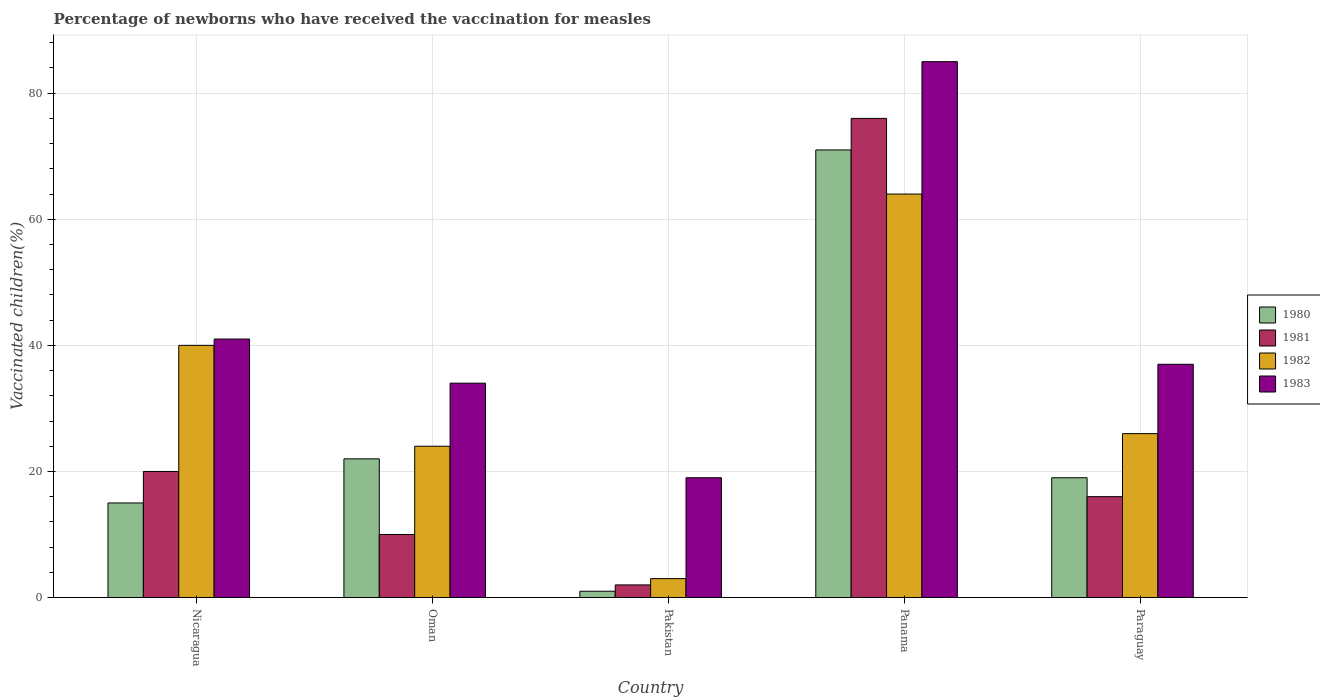How many groups of bars are there?
Offer a very short reply. 5. How many bars are there on the 1st tick from the right?
Offer a very short reply. 4. What is the label of the 2nd group of bars from the left?
Provide a succinct answer. Oman. In how many cases, is the number of bars for a given country not equal to the number of legend labels?
Provide a short and direct response. 0. What is the percentage of vaccinated children in 1983 in Pakistan?
Your answer should be compact. 19. Across all countries, what is the maximum percentage of vaccinated children in 1980?
Provide a short and direct response. 71. In which country was the percentage of vaccinated children in 1981 maximum?
Your answer should be very brief. Panama. What is the total percentage of vaccinated children in 1980 in the graph?
Give a very brief answer. 128. What is the difference between the percentage of vaccinated children in 1982 in Oman and the percentage of vaccinated children in 1981 in Panama?
Provide a short and direct response. -52. What is the average percentage of vaccinated children in 1980 per country?
Give a very brief answer. 25.6. What is the difference between the percentage of vaccinated children of/in 1982 and percentage of vaccinated children of/in 1981 in Oman?
Provide a short and direct response. 14. In how many countries, is the percentage of vaccinated children in 1983 greater than 44 %?
Provide a succinct answer. 1. What is the ratio of the percentage of vaccinated children in 1981 in Nicaragua to that in Paraguay?
Keep it short and to the point. 1.25. Is the percentage of vaccinated children in 1980 in Pakistan less than that in Panama?
Your answer should be very brief. Yes. What is the difference between the highest and the second highest percentage of vaccinated children in 1981?
Offer a very short reply. -60. What is the difference between the highest and the lowest percentage of vaccinated children in 1981?
Your answer should be compact. 74. In how many countries, is the percentage of vaccinated children in 1982 greater than the average percentage of vaccinated children in 1982 taken over all countries?
Provide a short and direct response. 2. Is it the case that in every country, the sum of the percentage of vaccinated children in 1982 and percentage of vaccinated children in 1980 is greater than the sum of percentage of vaccinated children in 1983 and percentage of vaccinated children in 1981?
Your answer should be compact. No. What is the difference between two consecutive major ticks on the Y-axis?
Keep it short and to the point. 20. Where does the legend appear in the graph?
Offer a very short reply. Center right. How many legend labels are there?
Give a very brief answer. 4. What is the title of the graph?
Your answer should be very brief. Percentage of newborns who have received the vaccination for measles. Does "2006" appear as one of the legend labels in the graph?
Offer a terse response. No. What is the label or title of the X-axis?
Your response must be concise. Country. What is the label or title of the Y-axis?
Keep it short and to the point. Vaccinated children(%). What is the Vaccinated children(%) in 1980 in Nicaragua?
Keep it short and to the point. 15. What is the Vaccinated children(%) in 1981 in Pakistan?
Make the answer very short. 2. What is the Vaccinated children(%) in 1983 in Panama?
Provide a short and direct response. 85. What is the Vaccinated children(%) of 1982 in Paraguay?
Your response must be concise. 26. What is the Vaccinated children(%) of 1983 in Paraguay?
Your answer should be very brief. 37. Across all countries, what is the maximum Vaccinated children(%) in 1980?
Provide a succinct answer. 71. Across all countries, what is the maximum Vaccinated children(%) in 1981?
Offer a very short reply. 76. Across all countries, what is the maximum Vaccinated children(%) of 1983?
Your response must be concise. 85. Across all countries, what is the minimum Vaccinated children(%) of 1982?
Give a very brief answer. 3. Across all countries, what is the minimum Vaccinated children(%) in 1983?
Ensure brevity in your answer.  19. What is the total Vaccinated children(%) in 1980 in the graph?
Offer a terse response. 128. What is the total Vaccinated children(%) in 1981 in the graph?
Your answer should be compact. 124. What is the total Vaccinated children(%) in 1982 in the graph?
Give a very brief answer. 157. What is the total Vaccinated children(%) of 1983 in the graph?
Give a very brief answer. 216. What is the difference between the Vaccinated children(%) in 1981 in Nicaragua and that in Oman?
Your answer should be compact. 10. What is the difference between the Vaccinated children(%) in 1982 in Nicaragua and that in Oman?
Your answer should be very brief. 16. What is the difference between the Vaccinated children(%) of 1980 in Nicaragua and that in Panama?
Provide a short and direct response. -56. What is the difference between the Vaccinated children(%) of 1981 in Nicaragua and that in Panama?
Provide a short and direct response. -56. What is the difference between the Vaccinated children(%) in 1983 in Nicaragua and that in Panama?
Your answer should be very brief. -44. What is the difference between the Vaccinated children(%) of 1983 in Nicaragua and that in Paraguay?
Make the answer very short. 4. What is the difference between the Vaccinated children(%) in 1980 in Oman and that in Pakistan?
Your response must be concise. 21. What is the difference between the Vaccinated children(%) in 1981 in Oman and that in Pakistan?
Ensure brevity in your answer.  8. What is the difference between the Vaccinated children(%) in 1982 in Oman and that in Pakistan?
Provide a succinct answer. 21. What is the difference between the Vaccinated children(%) of 1983 in Oman and that in Pakistan?
Your answer should be compact. 15. What is the difference between the Vaccinated children(%) of 1980 in Oman and that in Panama?
Ensure brevity in your answer.  -49. What is the difference between the Vaccinated children(%) of 1981 in Oman and that in Panama?
Provide a short and direct response. -66. What is the difference between the Vaccinated children(%) in 1983 in Oman and that in Panama?
Provide a short and direct response. -51. What is the difference between the Vaccinated children(%) in 1983 in Oman and that in Paraguay?
Give a very brief answer. -3. What is the difference between the Vaccinated children(%) in 1980 in Pakistan and that in Panama?
Your answer should be very brief. -70. What is the difference between the Vaccinated children(%) of 1981 in Pakistan and that in Panama?
Keep it short and to the point. -74. What is the difference between the Vaccinated children(%) of 1982 in Pakistan and that in Panama?
Provide a short and direct response. -61. What is the difference between the Vaccinated children(%) in 1983 in Pakistan and that in Panama?
Give a very brief answer. -66. What is the difference between the Vaccinated children(%) of 1980 in Pakistan and that in Paraguay?
Offer a terse response. -18. What is the difference between the Vaccinated children(%) in 1981 in Pakistan and that in Paraguay?
Ensure brevity in your answer.  -14. What is the difference between the Vaccinated children(%) in 1981 in Panama and that in Paraguay?
Provide a succinct answer. 60. What is the difference between the Vaccinated children(%) in 1980 in Nicaragua and the Vaccinated children(%) in 1982 in Oman?
Offer a very short reply. -9. What is the difference between the Vaccinated children(%) in 1980 in Nicaragua and the Vaccinated children(%) in 1983 in Oman?
Ensure brevity in your answer.  -19. What is the difference between the Vaccinated children(%) in 1981 in Nicaragua and the Vaccinated children(%) in 1982 in Oman?
Your response must be concise. -4. What is the difference between the Vaccinated children(%) of 1980 in Nicaragua and the Vaccinated children(%) of 1981 in Pakistan?
Provide a short and direct response. 13. What is the difference between the Vaccinated children(%) of 1980 in Nicaragua and the Vaccinated children(%) of 1982 in Pakistan?
Make the answer very short. 12. What is the difference between the Vaccinated children(%) of 1980 in Nicaragua and the Vaccinated children(%) of 1981 in Panama?
Give a very brief answer. -61. What is the difference between the Vaccinated children(%) in 1980 in Nicaragua and the Vaccinated children(%) in 1982 in Panama?
Your response must be concise. -49. What is the difference between the Vaccinated children(%) in 1980 in Nicaragua and the Vaccinated children(%) in 1983 in Panama?
Offer a terse response. -70. What is the difference between the Vaccinated children(%) in 1981 in Nicaragua and the Vaccinated children(%) in 1982 in Panama?
Provide a short and direct response. -44. What is the difference between the Vaccinated children(%) of 1981 in Nicaragua and the Vaccinated children(%) of 1983 in Panama?
Your answer should be very brief. -65. What is the difference between the Vaccinated children(%) of 1982 in Nicaragua and the Vaccinated children(%) of 1983 in Panama?
Offer a terse response. -45. What is the difference between the Vaccinated children(%) of 1980 in Nicaragua and the Vaccinated children(%) of 1982 in Paraguay?
Make the answer very short. -11. What is the difference between the Vaccinated children(%) in 1981 in Nicaragua and the Vaccinated children(%) in 1982 in Paraguay?
Keep it short and to the point. -6. What is the difference between the Vaccinated children(%) of 1981 in Nicaragua and the Vaccinated children(%) of 1983 in Paraguay?
Make the answer very short. -17. What is the difference between the Vaccinated children(%) in 1980 in Oman and the Vaccinated children(%) in 1981 in Pakistan?
Provide a succinct answer. 20. What is the difference between the Vaccinated children(%) of 1980 in Oman and the Vaccinated children(%) of 1983 in Pakistan?
Give a very brief answer. 3. What is the difference between the Vaccinated children(%) in 1981 in Oman and the Vaccinated children(%) in 1983 in Pakistan?
Offer a very short reply. -9. What is the difference between the Vaccinated children(%) of 1980 in Oman and the Vaccinated children(%) of 1981 in Panama?
Provide a short and direct response. -54. What is the difference between the Vaccinated children(%) in 1980 in Oman and the Vaccinated children(%) in 1982 in Panama?
Your answer should be compact. -42. What is the difference between the Vaccinated children(%) in 1980 in Oman and the Vaccinated children(%) in 1983 in Panama?
Offer a terse response. -63. What is the difference between the Vaccinated children(%) of 1981 in Oman and the Vaccinated children(%) of 1982 in Panama?
Provide a short and direct response. -54. What is the difference between the Vaccinated children(%) of 1981 in Oman and the Vaccinated children(%) of 1983 in Panama?
Offer a very short reply. -75. What is the difference between the Vaccinated children(%) of 1982 in Oman and the Vaccinated children(%) of 1983 in Panama?
Your answer should be compact. -61. What is the difference between the Vaccinated children(%) in 1982 in Oman and the Vaccinated children(%) in 1983 in Paraguay?
Your answer should be very brief. -13. What is the difference between the Vaccinated children(%) of 1980 in Pakistan and the Vaccinated children(%) of 1981 in Panama?
Ensure brevity in your answer.  -75. What is the difference between the Vaccinated children(%) in 1980 in Pakistan and the Vaccinated children(%) in 1982 in Panama?
Your answer should be compact. -63. What is the difference between the Vaccinated children(%) in 1980 in Pakistan and the Vaccinated children(%) in 1983 in Panama?
Your answer should be compact. -84. What is the difference between the Vaccinated children(%) of 1981 in Pakistan and the Vaccinated children(%) of 1982 in Panama?
Provide a short and direct response. -62. What is the difference between the Vaccinated children(%) of 1981 in Pakistan and the Vaccinated children(%) of 1983 in Panama?
Ensure brevity in your answer.  -83. What is the difference between the Vaccinated children(%) in 1982 in Pakistan and the Vaccinated children(%) in 1983 in Panama?
Keep it short and to the point. -82. What is the difference between the Vaccinated children(%) in 1980 in Pakistan and the Vaccinated children(%) in 1981 in Paraguay?
Your answer should be compact. -15. What is the difference between the Vaccinated children(%) of 1980 in Pakistan and the Vaccinated children(%) of 1983 in Paraguay?
Your answer should be compact. -36. What is the difference between the Vaccinated children(%) of 1981 in Pakistan and the Vaccinated children(%) of 1982 in Paraguay?
Your answer should be very brief. -24. What is the difference between the Vaccinated children(%) in 1981 in Pakistan and the Vaccinated children(%) in 1983 in Paraguay?
Make the answer very short. -35. What is the difference between the Vaccinated children(%) of 1982 in Pakistan and the Vaccinated children(%) of 1983 in Paraguay?
Provide a succinct answer. -34. What is the difference between the Vaccinated children(%) in 1980 in Panama and the Vaccinated children(%) in 1981 in Paraguay?
Ensure brevity in your answer.  55. What is the difference between the Vaccinated children(%) in 1980 in Panama and the Vaccinated children(%) in 1982 in Paraguay?
Provide a succinct answer. 45. What is the difference between the Vaccinated children(%) in 1981 in Panama and the Vaccinated children(%) in 1983 in Paraguay?
Ensure brevity in your answer.  39. What is the difference between the Vaccinated children(%) of 1982 in Panama and the Vaccinated children(%) of 1983 in Paraguay?
Give a very brief answer. 27. What is the average Vaccinated children(%) of 1980 per country?
Provide a succinct answer. 25.6. What is the average Vaccinated children(%) of 1981 per country?
Provide a succinct answer. 24.8. What is the average Vaccinated children(%) in 1982 per country?
Keep it short and to the point. 31.4. What is the average Vaccinated children(%) of 1983 per country?
Your answer should be very brief. 43.2. What is the difference between the Vaccinated children(%) in 1980 and Vaccinated children(%) in 1981 in Nicaragua?
Provide a short and direct response. -5. What is the difference between the Vaccinated children(%) in 1981 and Vaccinated children(%) in 1982 in Nicaragua?
Offer a terse response. -20. What is the difference between the Vaccinated children(%) in 1981 and Vaccinated children(%) in 1982 in Oman?
Your answer should be compact. -14. What is the difference between the Vaccinated children(%) of 1982 and Vaccinated children(%) of 1983 in Oman?
Make the answer very short. -10. What is the difference between the Vaccinated children(%) in 1981 and Vaccinated children(%) in 1982 in Pakistan?
Provide a succinct answer. -1. What is the difference between the Vaccinated children(%) of 1982 and Vaccinated children(%) of 1983 in Pakistan?
Make the answer very short. -16. What is the difference between the Vaccinated children(%) of 1980 and Vaccinated children(%) of 1982 in Panama?
Make the answer very short. 7. What is the difference between the Vaccinated children(%) in 1981 and Vaccinated children(%) in 1982 in Panama?
Offer a very short reply. 12. What is the difference between the Vaccinated children(%) of 1981 and Vaccinated children(%) of 1983 in Panama?
Offer a terse response. -9. What is the difference between the Vaccinated children(%) of 1982 and Vaccinated children(%) of 1983 in Panama?
Offer a terse response. -21. What is the difference between the Vaccinated children(%) in 1980 and Vaccinated children(%) in 1981 in Paraguay?
Provide a short and direct response. 3. What is the difference between the Vaccinated children(%) in 1980 and Vaccinated children(%) in 1983 in Paraguay?
Give a very brief answer. -18. What is the difference between the Vaccinated children(%) in 1981 and Vaccinated children(%) in 1982 in Paraguay?
Your response must be concise. -10. What is the difference between the Vaccinated children(%) in 1981 and Vaccinated children(%) in 1983 in Paraguay?
Your response must be concise. -21. What is the ratio of the Vaccinated children(%) in 1980 in Nicaragua to that in Oman?
Make the answer very short. 0.68. What is the ratio of the Vaccinated children(%) in 1981 in Nicaragua to that in Oman?
Keep it short and to the point. 2. What is the ratio of the Vaccinated children(%) of 1982 in Nicaragua to that in Oman?
Ensure brevity in your answer.  1.67. What is the ratio of the Vaccinated children(%) of 1983 in Nicaragua to that in Oman?
Make the answer very short. 1.21. What is the ratio of the Vaccinated children(%) of 1980 in Nicaragua to that in Pakistan?
Offer a very short reply. 15. What is the ratio of the Vaccinated children(%) in 1981 in Nicaragua to that in Pakistan?
Ensure brevity in your answer.  10. What is the ratio of the Vaccinated children(%) in 1982 in Nicaragua to that in Pakistan?
Your response must be concise. 13.33. What is the ratio of the Vaccinated children(%) in 1983 in Nicaragua to that in Pakistan?
Ensure brevity in your answer.  2.16. What is the ratio of the Vaccinated children(%) in 1980 in Nicaragua to that in Panama?
Your answer should be very brief. 0.21. What is the ratio of the Vaccinated children(%) of 1981 in Nicaragua to that in Panama?
Your response must be concise. 0.26. What is the ratio of the Vaccinated children(%) in 1983 in Nicaragua to that in Panama?
Your answer should be compact. 0.48. What is the ratio of the Vaccinated children(%) in 1980 in Nicaragua to that in Paraguay?
Your answer should be very brief. 0.79. What is the ratio of the Vaccinated children(%) of 1982 in Nicaragua to that in Paraguay?
Your response must be concise. 1.54. What is the ratio of the Vaccinated children(%) in 1983 in Nicaragua to that in Paraguay?
Your response must be concise. 1.11. What is the ratio of the Vaccinated children(%) in 1981 in Oman to that in Pakistan?
Provide a succinct answer. 5. What is the ratio of the Vaccinated children(%) of 1983 in Oman to that in Pakistan?
Give a very brief answer. 1.79. What is the ratio of the Vaccinated children(%) in 1980 in Oman to that in Panama?
Make the answer very short. 0.31. What is the ratio of the Vaccinated children(%) of 1981 in Oman to that in Panama?
Provide a succinct answer. 0.13. What is the ratio of the Vaccinated children(%) of 1982 in Oman to that in Panama?
Make the answer very short. 0.38. What is the ratio of the Vaccinated children(%) in 1980 in Oman to that in Paraguay?
Ensure brevity in your answer.  1.16. What is the ratio of the Vaccinated children(%) of 1981 in Oman to that in Paraguay?
Give a very brief answer. 0.62. What is the ratio of the Vaccinated children(%) in 1982 in Oman to that in Paraguay?
Provide a succinct answer. 0.92. What is the ratio of the Vaccinated children(%) in 1983 in Oman to that in Paraguay?
Provide a succinct answer. 0.92. What is the ratio of the Vaccinated children(%) of 1980 in Pakistan to that in Panama?
Your answer should be very brief. 0.01. What is the ratio of the Vaccinated children(%) in 1981 in Pakistan to that in Panama?
Make the answer very short. 0.03. What is the ratio of the Vaccinated children(%) in 1982 in Pakistan to that in Panama?
Give a very brief answer. 0.05. What is the ratio of the Vaccinated children(%) of 1983 in Pakistan to that in Panama?
Offer a very short reply. 0.22. What is the ratio of the Vaccinated children(%) of 1980 in Pakistan to that in Paraguay?
Make the answer very short. 0.05. What is the ratio of the Vaccinated children(%) in 1981 in Pakistan to that in Paraguay?
Provide a succinct answer. 0.12. What is the ratio of the Vaccinated children(%) of 1982 in Pakistan to that in Paraguay?
Give a very brief answer. 0.12. What is the ratio of the Vaccinated children(%) of 1983 in Pakistan to that in Paraguay?
Your answer should be very brief. 0.51. What is the ratio of the Vaccinated children(%) in 1980 in Panama to that in Paraguay?
Provide a short and direct response. 3.74. What is the ratio of the Vaccinated children(%) of 1981 in Panama to that in Paraguay?
Offer a very short reply. 4.75. What is the ratio of the Vaccinated children(%) in 1982 in Panama to that in Paraguay?
Provide a succinct answer. 2.46. What is the ratio of the Vaccinated children(%) of 1983 in Panama to that in Paraguay?
Your response must be concise. 2.3. What is the difference between the highest and the second highest Vaccinated children(%) of 1980?
Make the answer very short. 49. What is the difference between the highest and the second highest Vaccinated children(%) in 1981?
Offer a very short reply. 56. What is the difference between the highest and the second highest Vaccinated children(%) in 1982?
Provide a succinct answer. 24. What is the difference between the highest and the second highest Vaccinated children(%) of 1983?
Your answer should be compact. 44. What is the difference between the highest and the lowest Vaccinated children(%) of 1982?
Your response must be concise. 61. 